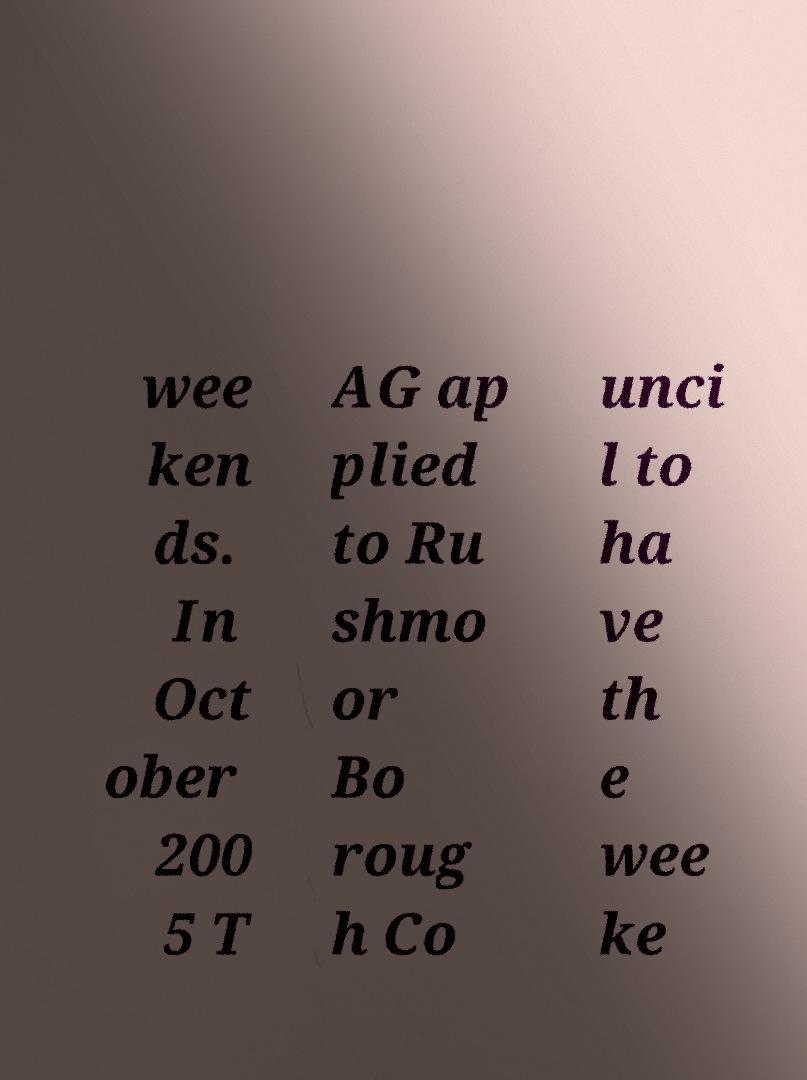There's text embedded in this image that I need extracted. Can you transcribe it verbatim? wee ken ds. In Oct ober 200 5 T AG ap plied to Ru shmo or Bo roug h Co unci l to ha ve th e wee ke 